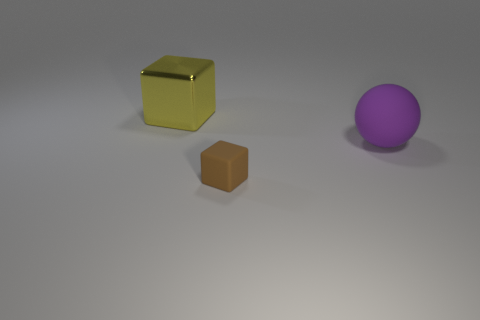Is there anything else that is the same material as the big cube?
Provide a short and direct response. No. How many other things are the same shape as the brown object?
Your response must be concise. 1. There is a small brown rubber cube that is left of the big purple sphere; is there a big yellow object on the right side of it?
Provide a succinct answer. No. How many metal objects are large blocks or big purple cylinders?
Ensure brevity in your answer.  1. The object that is both to the left of the big matte thing and right of the yellow object is made of what material?
Make the answer very short. Rubber. Are there any large rubber spheres that are behind the big object right of the block to the right of the big yellow metallic thing?
Ensure brevity in your answer.  No. There is a purple thing that is made of the same material as the brown cube; what shape is it?
Provide a succinct answer. Sphere. Are there fewer rubber blocks that are to the right of the purple sphere than large yellow objects that are behind the shiny block?
Make the answer very short. No. How many tiny objects are brown things or cyan rubber cylinders?
Make the answer very short. 1. There is a large thing to the left of the big purple matte object; is its shape the same as the matte object to the right of the rubber cube?
Give a very brief answer. No. 